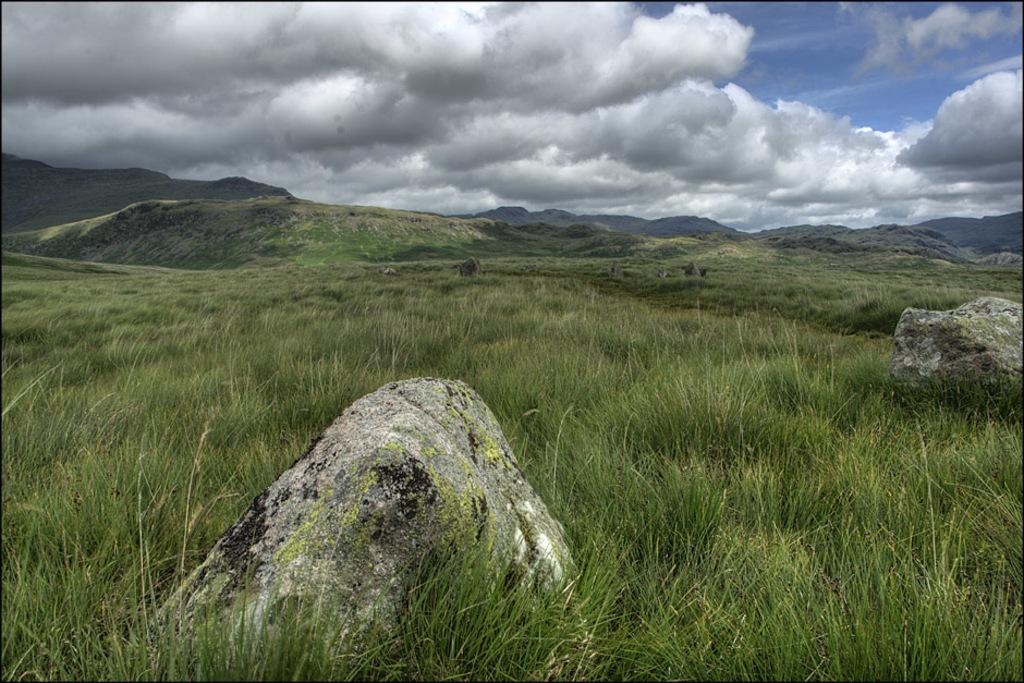What type of natural elements can be seen in the image? There are rocks and grass in the image. What geographical features are present in the image? There are hills in the image. What can be seen in the background of the image? The sky is visible in the background of the image. Where is the hospital located in the image? There is no hospital present in the image. What type of flowers can be seen growing among the rocks in the image? There are no flowers visible in the image; it only features rocks and grass. 